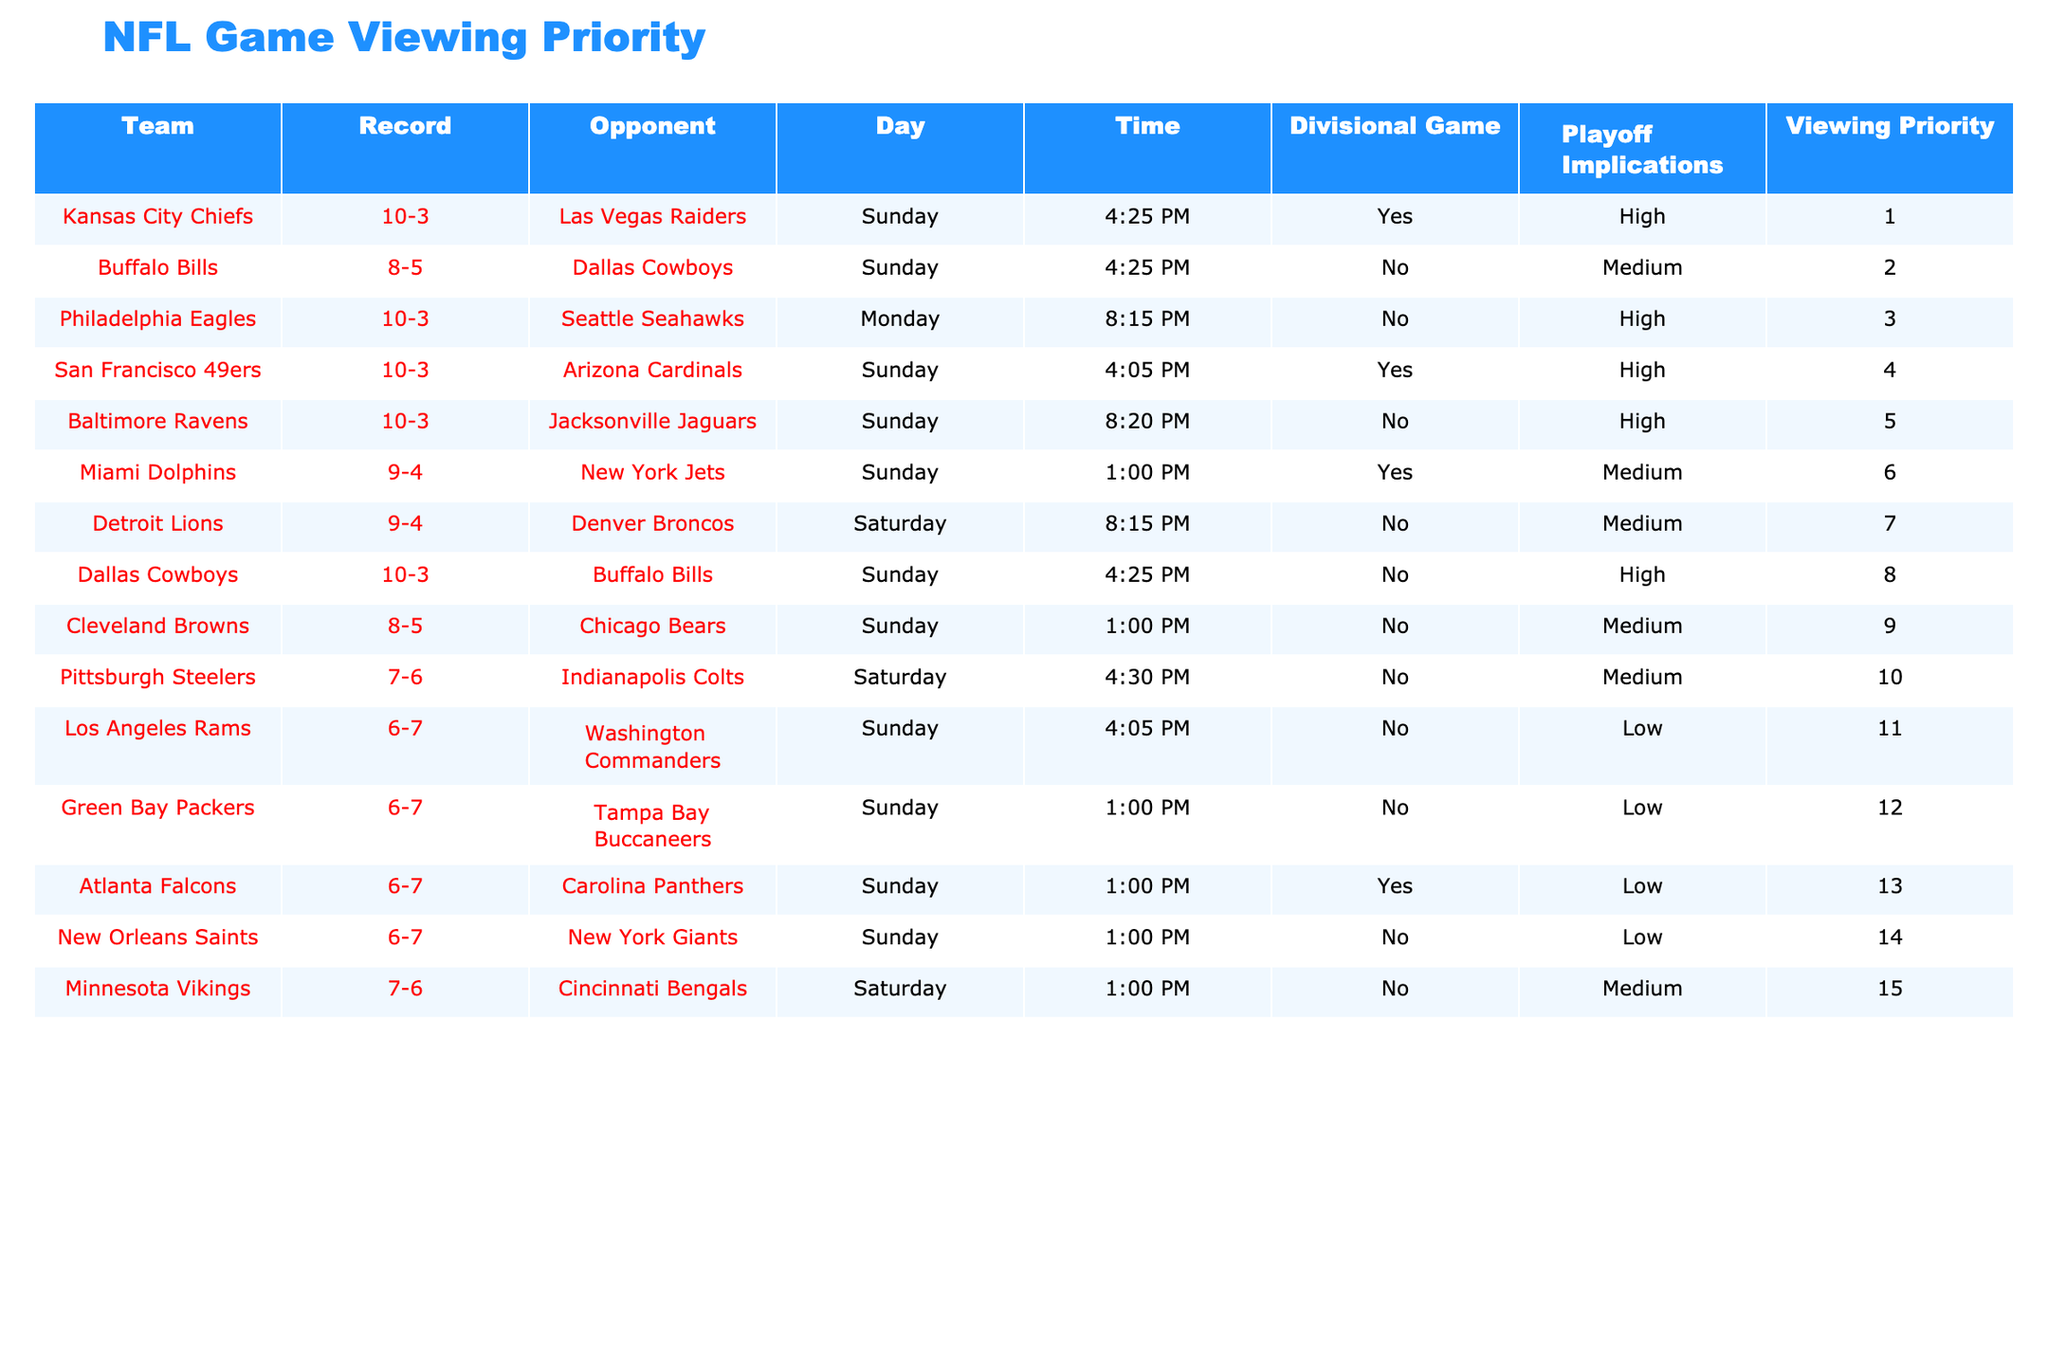What is the highest viewing priority among the teams listed? The table shows the "Viewing Priority" column for each team. The Kansas City Chiefs have the highest viewing priority listed as 1, which is the lowest numerical value indicating the top priority.
Answer: 1 Which team is scheduled to play on Monday? By checking the "Day" column, the Philadelphia Eagles are the only team listed with the game day of Monday.
Answer: Philadelphia Eagles Is there a team with a low viewing priority that is also playing on a Sunday? Looking at the "Viewing Priority" and "Day" columns, the Los Angeles Rams, Green Bay Packers, Atlanta Falcons, and New Orleans Saints all have low viewing priorities and are scheduled to play on Sunday.
Answer: Yes What is the combined record of the top three teams by viewing priority? The top three teams by viewing priority (Kansas City Chiefs, Buffalo Bills, and Philadelphia Eagles) have records of 10-3, 8-5, and 10-3, respectively. We convert these to total wins and losses: (10 + 8 + 10) wins and (3 + 5 + 3) losses = 28-11.
Answer: 28-11 Is the Baltimore Ravens game significant for playoff implications? By checking the "Playoff Implications" column for the Baltimore Ravens, it shows "High," meaning that they have significant playoff implications for their game.
Answer: Yes How many teams listed have a Sunday game schedule with divisional games? Looking at the "Divisional Game" column for Sunday teams, we find that the Kansas City Chiefs, San Francisco 49ers, Miami Dolphins, and Atlanta Falcons are marked as "Yes," totaling four teams.
Answer: 4 Which team has the latest game time on Sunday? Scanning the "Time" column on Sunday, the Baltimore Ravens' game at 8:20 PM is the latest scheduled time among the listed teams.
Answer: Baltimore Ravens What percentage of teams have playoff implications in their games? Out of the total 15 teams, 6 teams have "High" playoff implications. To find the percentage, we calculate (6/15) * 100 = 40%.
Answer: 40% 